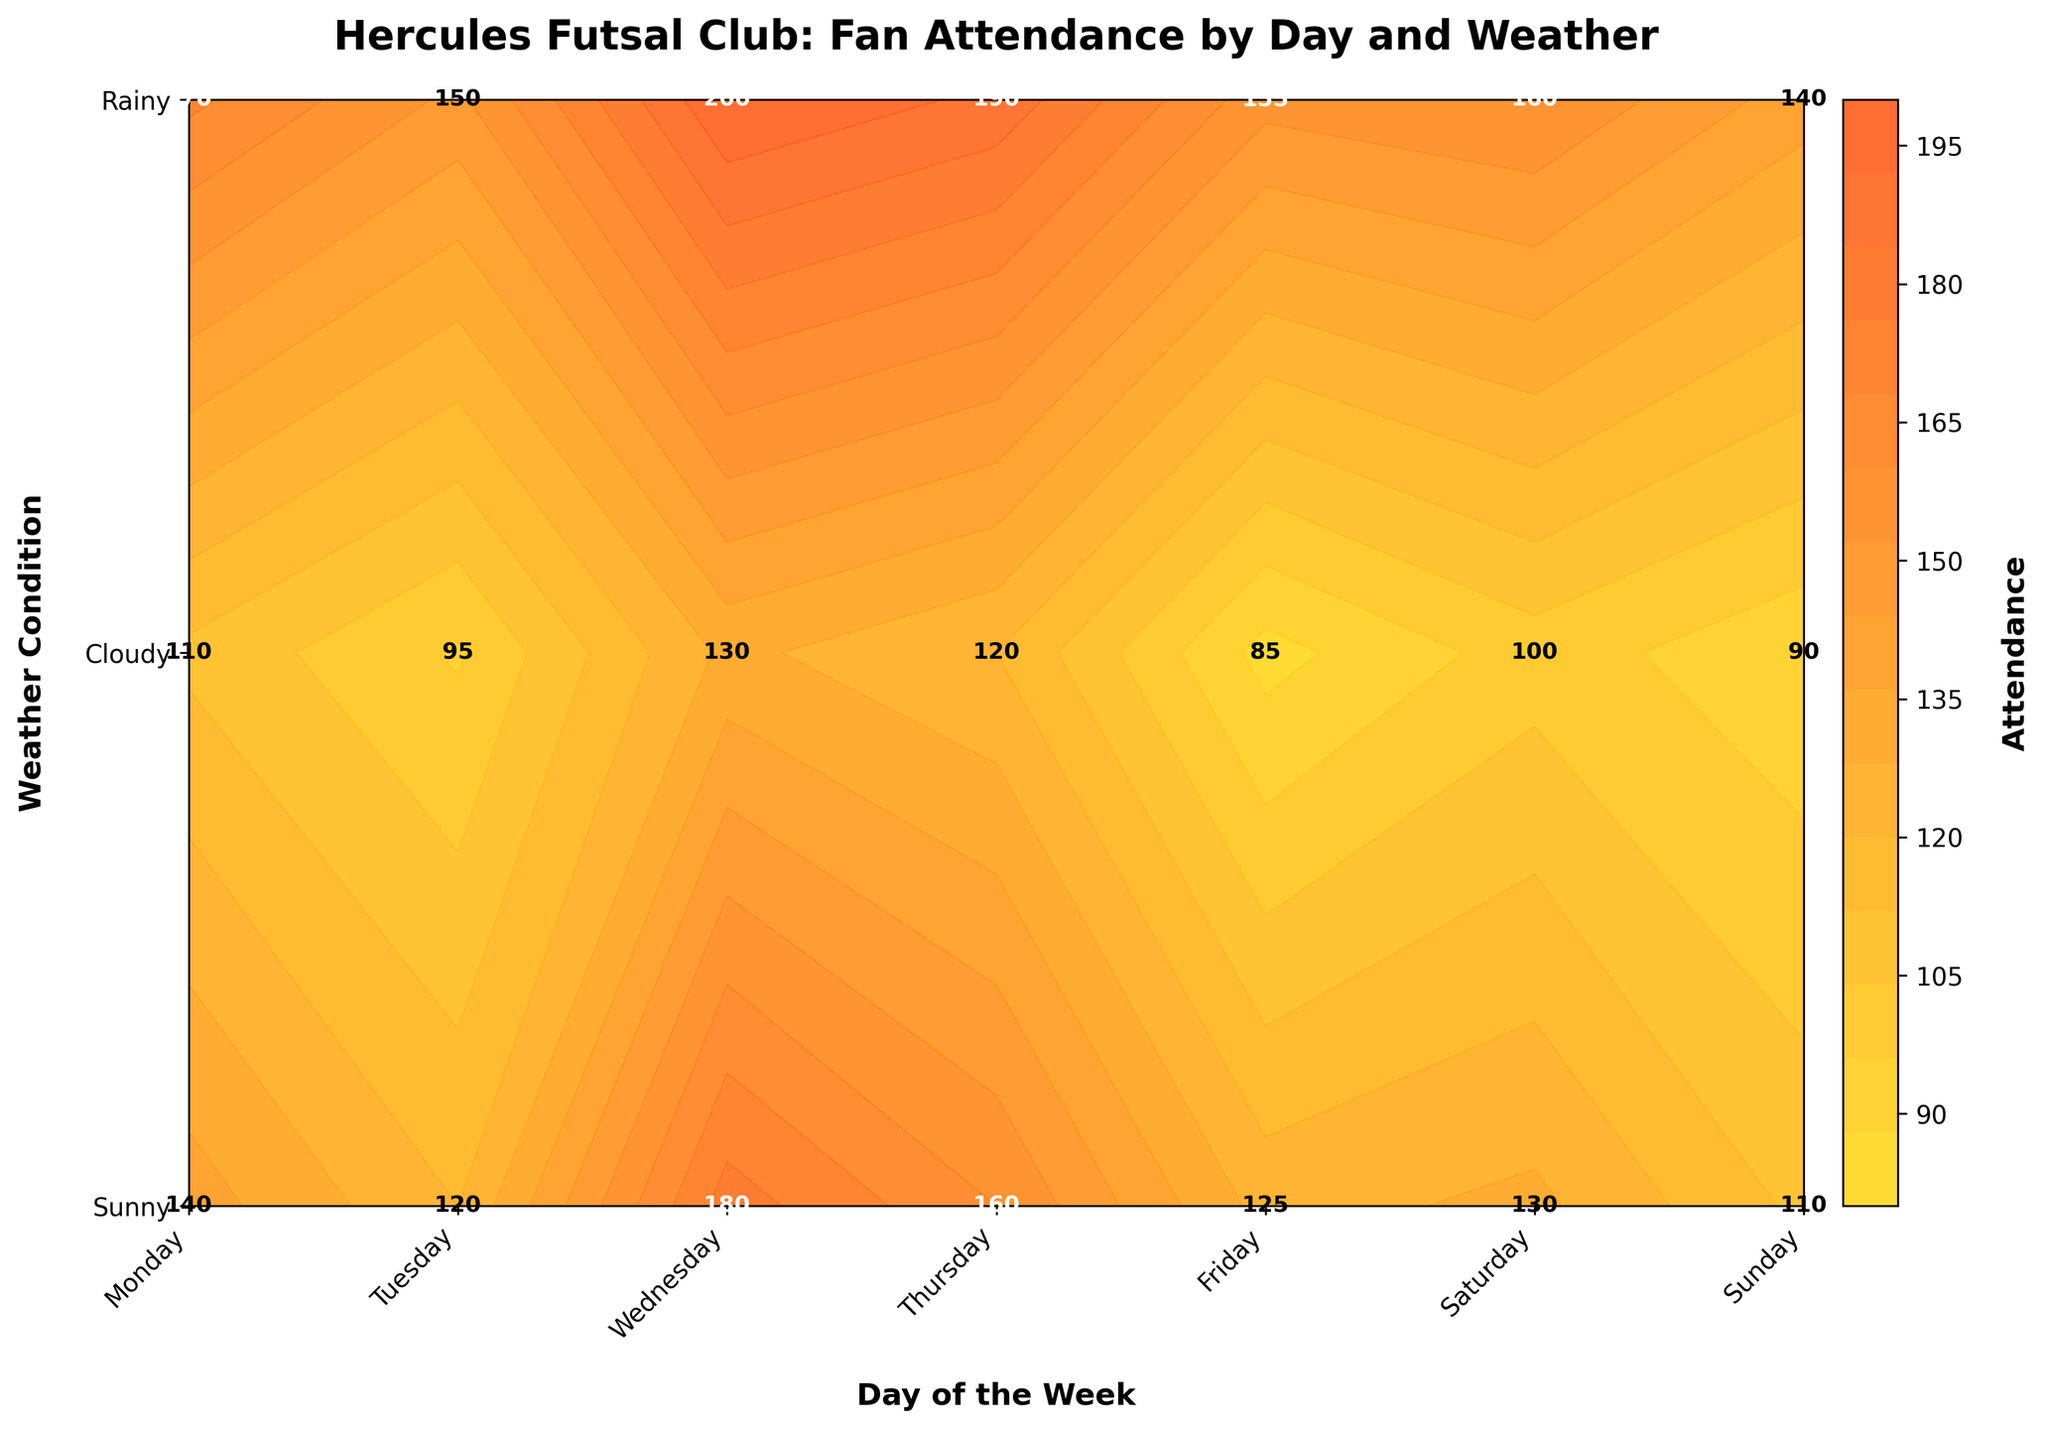How many levels of attendance are shown in the contour plot? The contour plot uses a color gradient with 15 levels to represent different attendance figures.
Answer: 15 Which day shows the highest attendance and what is the attendance number? On Saturdays with sunny weather, the attendance reaches its peak at 200, as indicated by the highest value on the plot.
Answer: Saturday, 200 How does the weather affect attendance on Fridays compared to Sundays? Comparing Friday and Sunday, sunny weather on both days yields high attendance (170 on Friday and 190 on Sunday). However, rain decreases attendance significantly for both days but slightly more on Fridays (110) than Sundays (120).
Answer: Attendance is lower on rainy days, more significantly on Fridays What is the average attendance for cloudy weather? Attendance on cloudy days: Monday (120), Tuesday (130), Wednesday (110), Thursday (125), Friday (140), Saturday (180), Sunday (160). Average = (120 + 130 + 110 + 125 + 140 + 180 + 160) / 7 = 965 / 7.
Answer: 137.86 Which weather condition generally results in the highest attendance? Inspecting the contour plot indicates that sunny weather consistently has higher attendance across all days compared to cloudy or rainy weather.
Answer: Sunny On which day is the attendance the lowest, for any weather condition? The lowest attendance is on Thursdays when it rains, marked at 85 in the plot.
Answer: Thursday, 85 What is the total attendance on rainy days throughout the week? Sum of attendances on rainy days: Monday (95), Tuesday (100), Wednesday (90), Thursday (85), Friday (110), Saturday (130), Sunday (120). Total = 95 + 100 + 90 + 85 + 110 + 130 + 120
Answer: 730 Compare the attendance on sunny and cloudy days for Saturdays. For Saturdays, the attendance on sunny days is 200, while on cloudy days it is 180, showing that sunny weather attracts more fans.
Answer: Sunny: 200, Cloudy: 180 Is there any day having a constant attendance across all weather conditions? No day has the same attendance across sunny, rainy, and cloudy conditions as per the plot’s highlighted values.
Answer: No What is the sum of attendances on Wednesdays for sunny and cloudy weather? Attendance on sunny (140) and cloudy (110) Wednesdays. Sum = 140 + 110
Answer: 250 